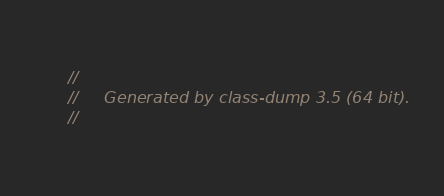<code> <loc_0><loc_0><loc_500><loc_500><_C_>//
//     Generated by class-dump 3.5 (64 bit).
//</code> 